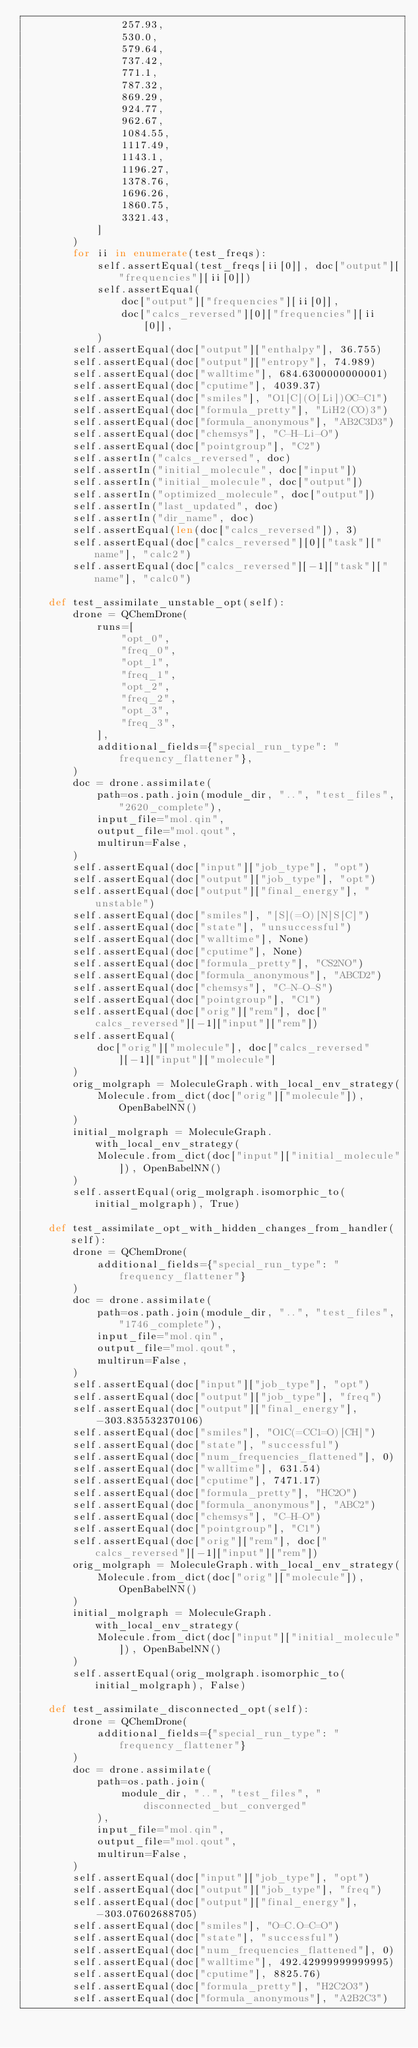<code> <loc_0><loc_0><loc_500><loc_500><_Python_>                257.93,
                530.0,
                579.64,
                737.42,
                771.1,
                787.32,
                869.29,
                924.77,
                962.67,
                1084.55,
                1117.49,
                1143.1,
                1196.27,
                1378.76,
                1696.26,
                1860.75,
                3321.43,
            ]
        )
        for ii in enumerate(test_freqs):
            self.assertEqual(test_freqs[ii[0]], doc["output"]["frequencies"][ii[0]])
            self.assertEqual(
                doc["output"]["frequencies"][ii[0]],
                doc["calcs_reversed"][0]["frequencies"][ii[0]],
            )
        self.assertEqual(doc["output"]["enthalpy"], 36.755)
        self.assertEqual(doc["output"]["entropy"], 74.989)
        self.assertEqual(doc["walltime"], 684.6300000000001)
        self.assertEqual(doc["cputime"], 4039.37)
        self.assertEqual(doc["smiles"], "O1[C](O[Li])OC=C1")
        self.assertEqual(doc["formula_pretty"], "LiH2(CO)3")
        self.assertEqual(doc["formula_anonymous"], "AB2C3D3")
        self.assertEqual(doc["chemsys"], "C-H-Li-O")
        self.assertEqual(doc["pointgroup"], "C2")
        self.assertIn("calcs_reversed", doc)
        self.assertIn("initial_molecule", doc["input"])
        self.assertIn("initial_molecule", doc["output"])
        self.assertIn("optimized_molecule", doc["output"])
        self.assertIn("last_updated", doc)
        self.assertIn("dir_name", doc)
        self.assertEqual(len(doc["calcs_reversed"]), 3)
        self.assertEqual(doc["calcs_reversed"][0]["task"]["name"], "calc2")
        self.assertEqual(doc["calcs_reversed"][-1]["task"]["name"], "calc0")

    def test_assimilate_unstable_opt(self):
        drone = QChemDrone(
            runs=[
                "opt_0",
                "freq_0",
                "opt_1",
                "freq_1",
                "opt_2",
                "freq_2",
                "opt_3",
                "freq_3",
            ],
            additional_fields={"special_run_type": "frequency_flattener"},
        )
        doc = drone.assimilate(
            path=os.path.join(module_dir, "..", "test_files", "2620_complete"),
            input_file="mol.qin",
            output_file="mol.qout",
            multirun=False,
        )
        self.assertEqual(doc["input"]["job_type"], "opt")
        self.assertEqual(doc["output"]["job_type"], "opt")
        self.assertEqual(doc["output"]["final_energy"], "unstable")
        self.assertEqual(doc["smiles"], "[S](=O)[N]S[C]")
        self.assertEqual(doc["state"], "unsuccessful")
        self.assertEqual(doc["walltime"], None)
        self.assertEqual(doc["cputime"], None)
        self.assertEqual(doc["formula_pretty"], "CS2NO")
        self.assertEqual(doc["formula_anonymous"], "ABCD2")
        self.assertEqual(doc["chemsys"], "C-N-O-S")
        self.assertEqual(doc["pointgroup"], "C1")
        self.assertEqual(doc["orig"]["rem"], doc["calcs_reversed"][-1]["input"]["rem"])
        self.assertEqual(
            doc["orig"]["molecule"], doc["calcs_reversed"][-1]["input"]["molecule"]
        )
        orig_molgraph = MoleculeGraph.with_local_env_strategy(
            Molecule.from_dict(doc["orig"]["molecule"]), OpenBabelNN()
        )
        initial_molgraph = MoleculeGraph.with_local_env_strategy(
            Molecule.from_dict(doc["input"]["initial_molecule"]), OpenBabelNN()
        )
        self.assertEqual(orig_molgraph.isomorphic_to(initial_molgraph), True)

    def test_assimilate_opt_with_hidden_changes_from_handler(self):
        drone = QChemDrone(
            additional_fields={"special_run_type": "frequency_flattener"}
        )
        doc = drone.assimilate(
            path=os.path.join(module_dir, "..", "test_files", "1746_complete"),
            input_file="mol.qin",
            output_file="mol.qout",
            multirun=False,
        )
        self.assertEqual(doc["input"]["job_type"], "opt")
        self.assertEqual(doc["output"]["job_type"], "freq")
        self.assertEqual(doc["output"]["final_energy"], -303.835532370106)
        self.assertEqual(doc["smiles"], "O1C(=CC1=O)[CH]")
        self.assertEqual(doc["state"], "successful")
        self.assertEqual(doc["num_frequencies_flattened"], 0)
        self.assertEqual(doc["walltime"], 631.54)
        self.assertEqual(doc["cputime"], 7471.17)
        self.assertEqual(doc["formula_pretty"], "HC2O")
        self.assertEqual(doc["formula_anonymous"], "ABC2")
        self.assertEqual(doc["chemsys"], "C-H-O")
        self.assertEqual(doc["pointgroup"], "C1")
        self.assertEqual(doc["orig"]["rem"], doc["calcs_reversed"][-1]["input"]["rem"])
        orig_molgraph = MoleculeGraph.with_local_env_strategy(
            Molecule.from_dict(doc["orig"]["molecule"]), OpenBabelNN()
        )
        initial_molgraph = MoleculeGraph.with_local_env_strategy(
            Molecule.from_dict(doc["input"]["initial_molecule"]), OpenBabelNN()
        )
        self.assertEqual(orig_molgraph.isomorphic_to(initial_molgraph), False)

    def test_assimilate_disconnected_opt(self):
        drone = QChemDrone(
            additional_fields={"special_run_type": "frequency_flattener"}
        )
        doc = drone.assimilate(
            path=os.path.join(
                module_dir, "..", "test_files", "disconnected_but_converged"
            ),
            input_file="mol.qin",
            output_file="mol.qout",
            multirun=False,
        )
        self.assertEqual(doc["input"]["job_type"], "opt")
        self.assertEqual(doc["output"]["job_type"], "freq")
        self.assertEqual(doc["output"]["final_energy"], -303.07602688705)
        self.assertEqual(doc["smiles"], "O=C.O=C=O")
        self.assertEqual(doc["state"], "successful")
        self.assertEqual(doc["num_frequencies_flattened"], 0)
        self.assertEqual(doc["walltime"], 492.42999999999995)
        self.assertEqual(doc["cputime"], 8825.76)
        self.assertEqual(doc["formula_pretty"], "H2C2O3")
        self.assertEqual(doc["formula_anonymous"], "A2B2C3")</code> 